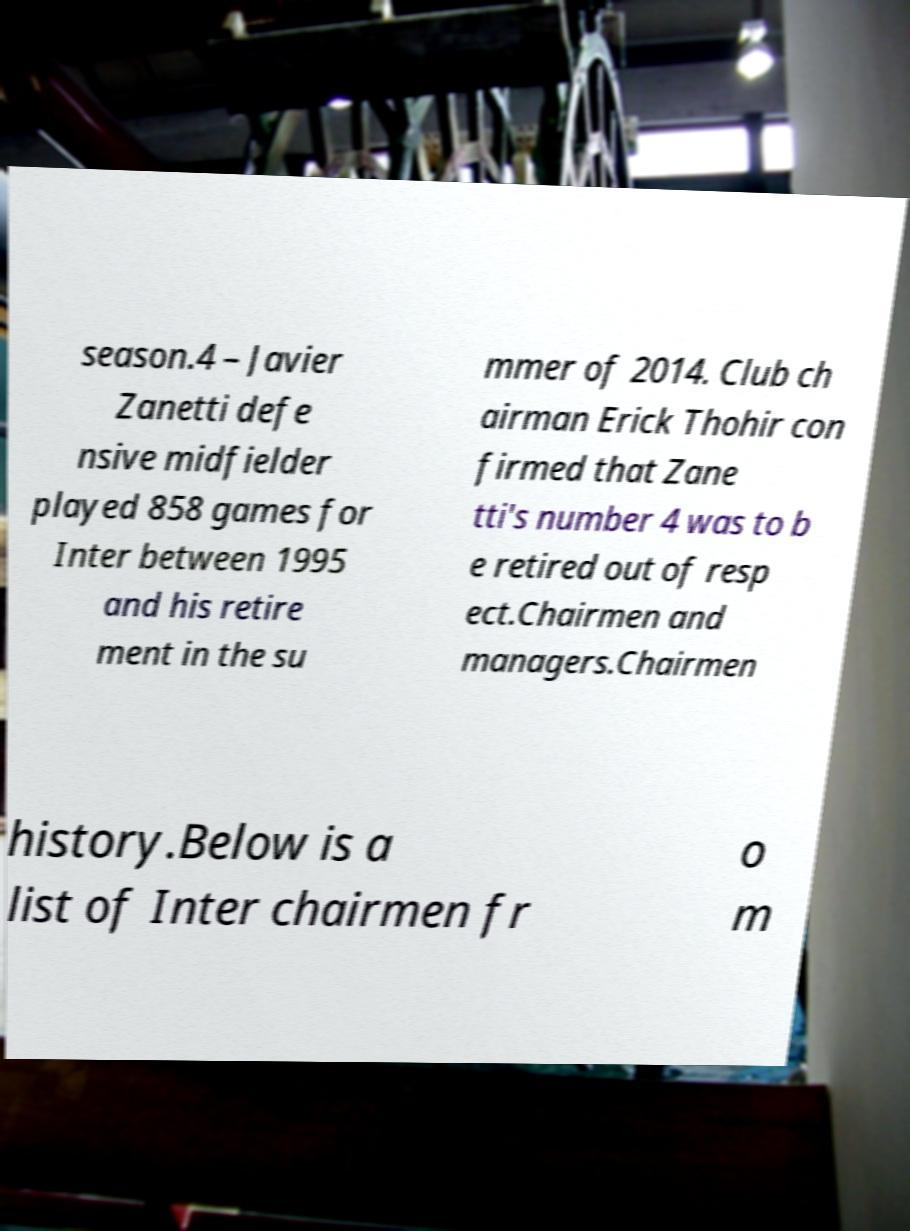Could you assist in decoding the text presented in this image and type it out clearly? season.4 – Javier Zanetti defe nsive midfielder played 858 games for Inter between 1995 and his retire ment in the su mmer of 2014. Club ch airman Erick Thohir con firmed that Zane tti's number 4 was to b e retired out of resp ect.Chairmen and managers.Chairmen history.Below is a list of Inter chairmen fr o m 